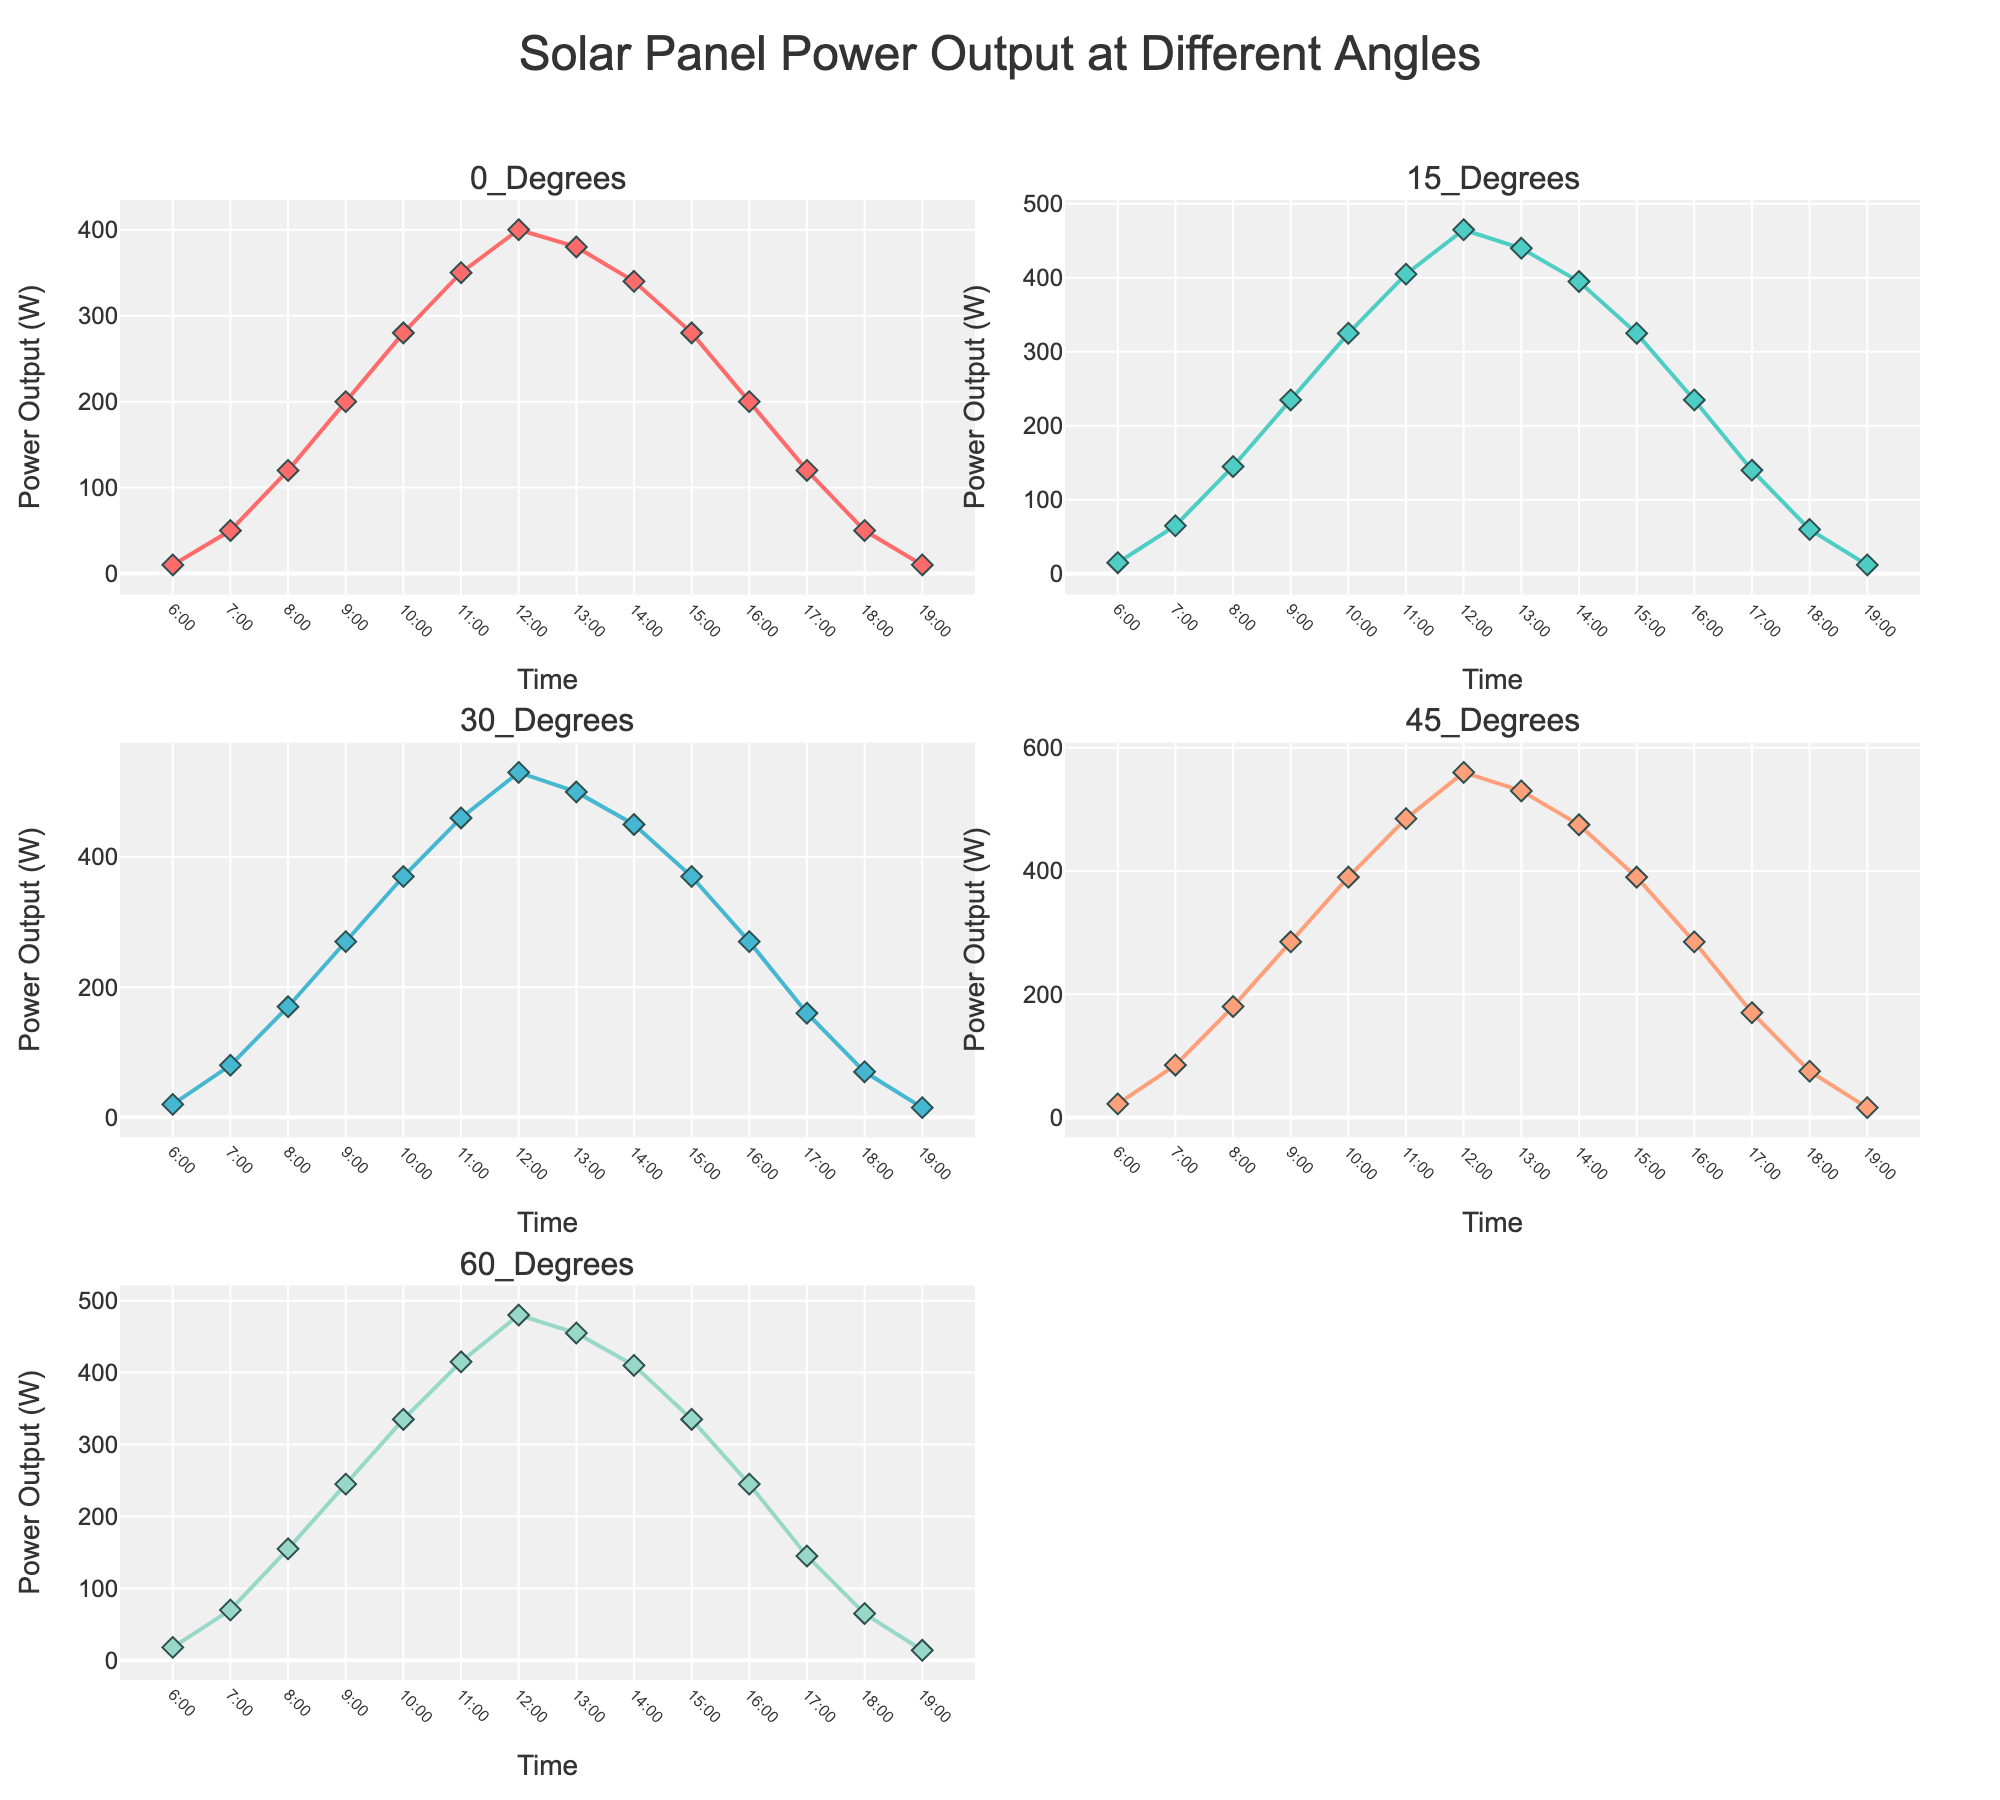which angle has the highest power output at 9:00 AM? To answer this, locate the 9:00 AM timestamp on each subplot and observe the power output values. Out of 0, 15, 30, 45, and 60 degrees, the angle with the highest power output is 45 degrees with a value of 285 W.
Answer: 45 degrees how does the power output at 0 degrees compare between 7:00 AM and 5:00 PM? Find the 0 degrees subplot and compare the power values at 7:00 AM and 5:00 PM. At 7:00 AM, the power output is 50 W, and at 5:00 PM, it is 120 W. Hence, the power output at 0 degrees is higher at 5:00 PM than at 7:00 AM.
Answer: Higher at 5:00 PM what is the trend of power output throughout the day at 30 degrees? Look at the 30 degrees subplot and observe the power output values from 6:00 AM to 7:00 PM. Power output starts low, increases to a peak at 12:00 PM, and then decreases back to a low value by 7:00 PM.
Answer: Increase until noon, then decrease at what time do all angles have their highest power output? Find the time at which each subplot (angle) shows its peak power output. All angles reach their maximum power output at 12:00 PM.
Answer: 12:00 PM which angle of inclination has the lowest power output at 12:00 PM? At 12:00 PM, compare the power output values for all angles. The angle with the lowest power output is 0 degrees with a value of 400 W.
Answer: 0 degrees how does the power output at 60 degrees change from 10:00 AM to 2:00 PM? Examine the 60 degrees subplot for power outputs at 10:00 AM and 2:00 PM. At 10:00 AM, the power output is 335 W, and at 2:00 PM, it is 410 W. This indicates an increase in power output.
Answer: Increases what is the average power output at 45 degrees from 12:00 PM to 3:00 PM? To find the average, sum the power output values at 45 degrees from 12:00 PM to 3:00 PM and divide by the number of observations. Values: 560 W, 530 W, 475 W, 390 W. Average = (560 + 530 + 475 + 390) / 4 = 488.75 W
Answer: 488.75 W compare the power output at 30 degrees at 8:00 AM and 6:00 PM. which time has a higher value? Compare the values at 8:00 AM (170 W) and 6:00 PM (70 W) from the 30 degrees subplot. The power output is higher at 8:00 AM.
Answer: 8:00 AM how many data points are there in the subplot for 15 degrees? Count the number of points on the 15 degrees subplot. There are 14 data points, corresponding to each hour from 6:00 AM to 7:00 PM.
Answer: 14 